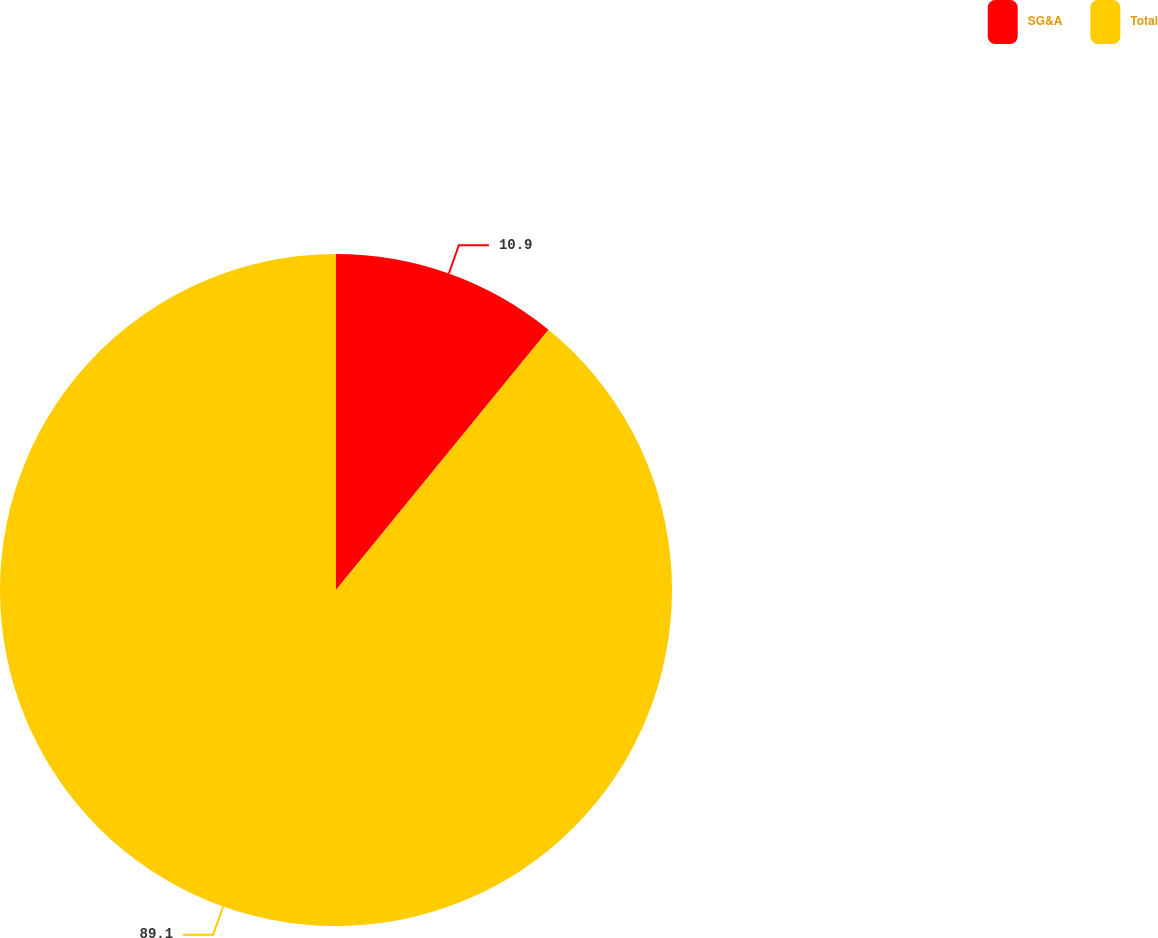<chart> <loc_0><loc_0><loc_500><loc_500><pie_chart><fcel>SG&A<fcel>Total<nl><fcel>10.9%<fcel>89.1%<nl></chart> 